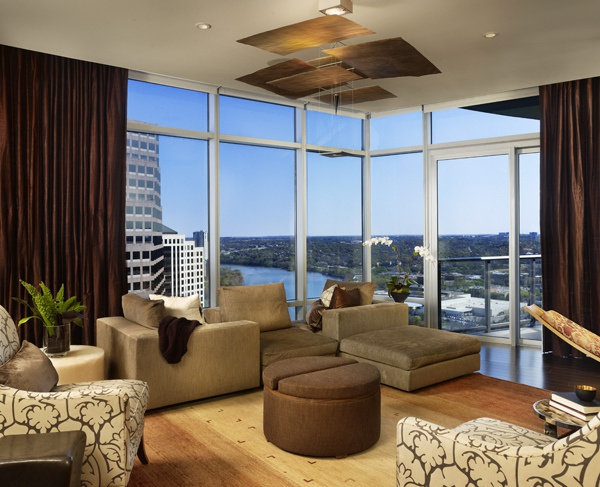Describe the objects in this image and their specific colors. I can see chair in gray, black, and tan tones, couch in gray, olive, black, and tan tones, chair in gray, tan, and maroon tones, couch in gray, tan, and maroon tones, and couch in gray and tan tones in this image. 